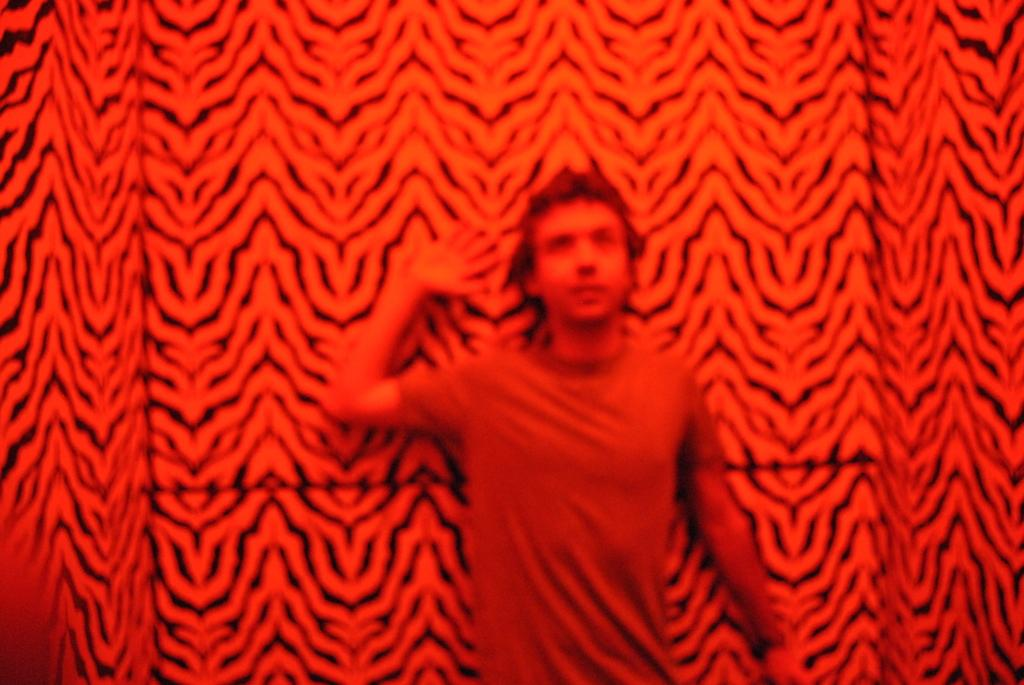What is the dominant color in the image? The image has a predominantly red color. Can you describe the person in the image? There is a man in the image. What is the man wearing? The man is wearing a t-shirt. What can be seen behind the man in the image? There is a wall in the image. How is the wall decorated? The wall has a red and black color pattern. What type of animal is biting the man in the image? There is no animal present in the image, nor is there any indication of a bite. 